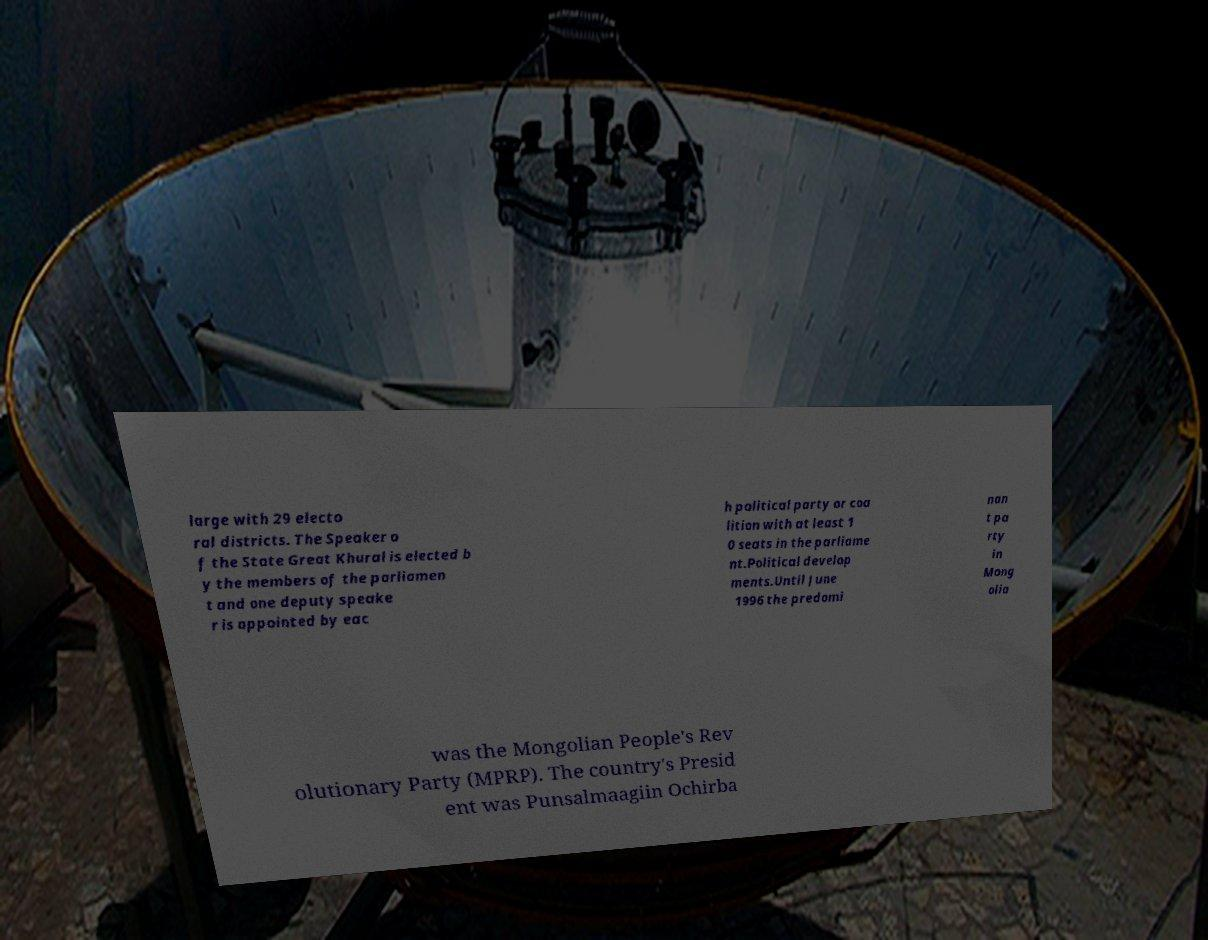Could you extract and type out the text from this image? large with 29 electo ral districts. The Speaker o f the State Great Khural is elected b y the members of the parliamen t and one deputy speake r is appointed by eac h political party or coa lition with at least 1 0 seats in the parliame nt.Political develop ments.Until June 1996 the predomi nan t pa rty in Mong olia was the Mongolian People's Rev olutionary Party (MPRP). The country's Presid ent was Punsalmaagiin Ochirba 